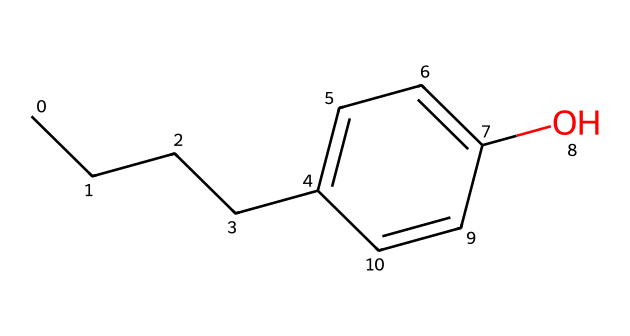What is the molecular formula of this compound? The molecular formula is derived from counting the number of each type of atom represented in the SMILES notation. The structure contains 10 carbon (C) atoms, 14 hydrogen (H) atoms, and 1 oxygen (O) atom, which gives us the formula C10H14O.
Answer: C10H14O How many rings are present in this chemical structure? In the given SMILES, there is a phenolic ring indicated by the 'c' characters combined with a single 'O' connected to it, but there are no additional rings. Thus, the answer is one.
Answer: 1 What is the functional group indicated in this chemical? The presence of the 'O' bonded to a carbon in the aromatic ring indicates a hydroxyl (-OH) functional group, which characterizes this chemical as a phenol.
Answer: hydroxyl What type of solvent is this chemical likely to dissolve in? Alkylphenols, due to the combination of a hydrophobic alkyl chain and a hydrophilic hydroxyl group, are likely to dissolve in both organic solvents and a small amount in water. However, they will be more soluble in organic solvents.
Answer: organic solvents How does the structure affect the toxicity of this compound in aquatic ecosystems? The alkyl group provides hydrophobic characteristics, which can increase bioaccumulation in aquatic organisms, while the hydroxyl group can cause reactivity with biological molecules, making it potentially toxic. This duality means it has a higher chance of adversely affecting marine life.
Answer: increased toxicity Which component in the structure is primarily responsible for its environmental persistence? The aromatic ring in the structure is stable and resistant to degradation, contributing to the overall environmental persistence of alkylphenols.
Answer: aromatic ring What kind of pollutants are alkylphenols classified as? Alkylphenols are classified under endocrine-disrupting chemicals due to their potential to interfere with hormonal systems in wildlife.
Answer: endocrine disruptors 